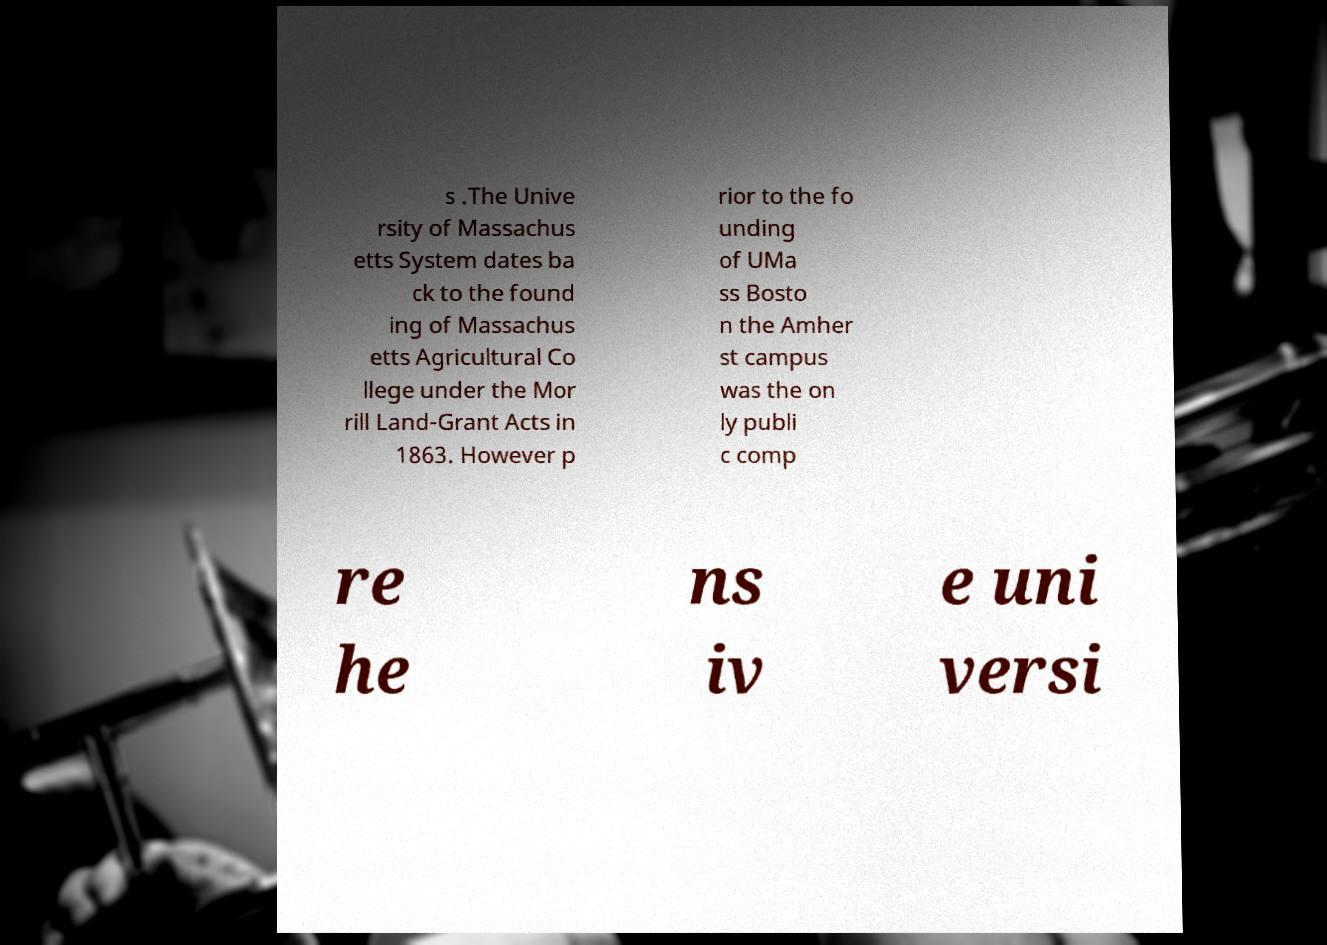I need the written content from this picture converted into text. Can you do that? s .The Unive rsity of Massachus etts System dates ba ck to the found ing of Massachus etts Agricultural Co llege under the Mor rill Land-Grant Acts in 1863. However p rior to the fo unding of UMa ss Bosto n the Amher st campus was the on ly publi c comp re he ns iv e uni versi 